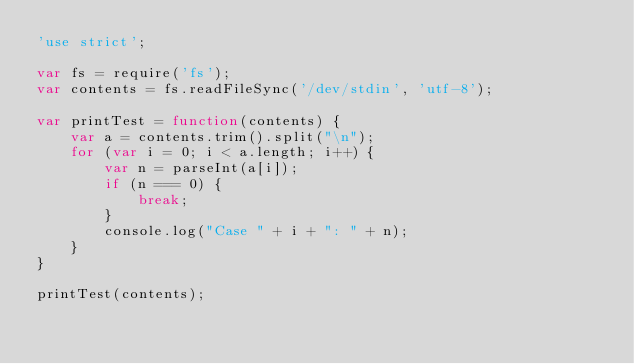<code> <loc_0><loc_0><loc_500><loc_500><_JavaScript_>'use strict';

var fs = require('fs');
var contents = fs.readFileSync('/dev/stdin', 'utf-8');

var printTest = function(contents) {
    var a = contents.trim().split("\n");
    for (var i = 0; i < a.length; i++) {
        var n = parseInt(a[i]);
        if (n === 0) {
            break;
        }
        console.log("Case " + i + ": " + n);
    }
}

printTest(contents);</code> 